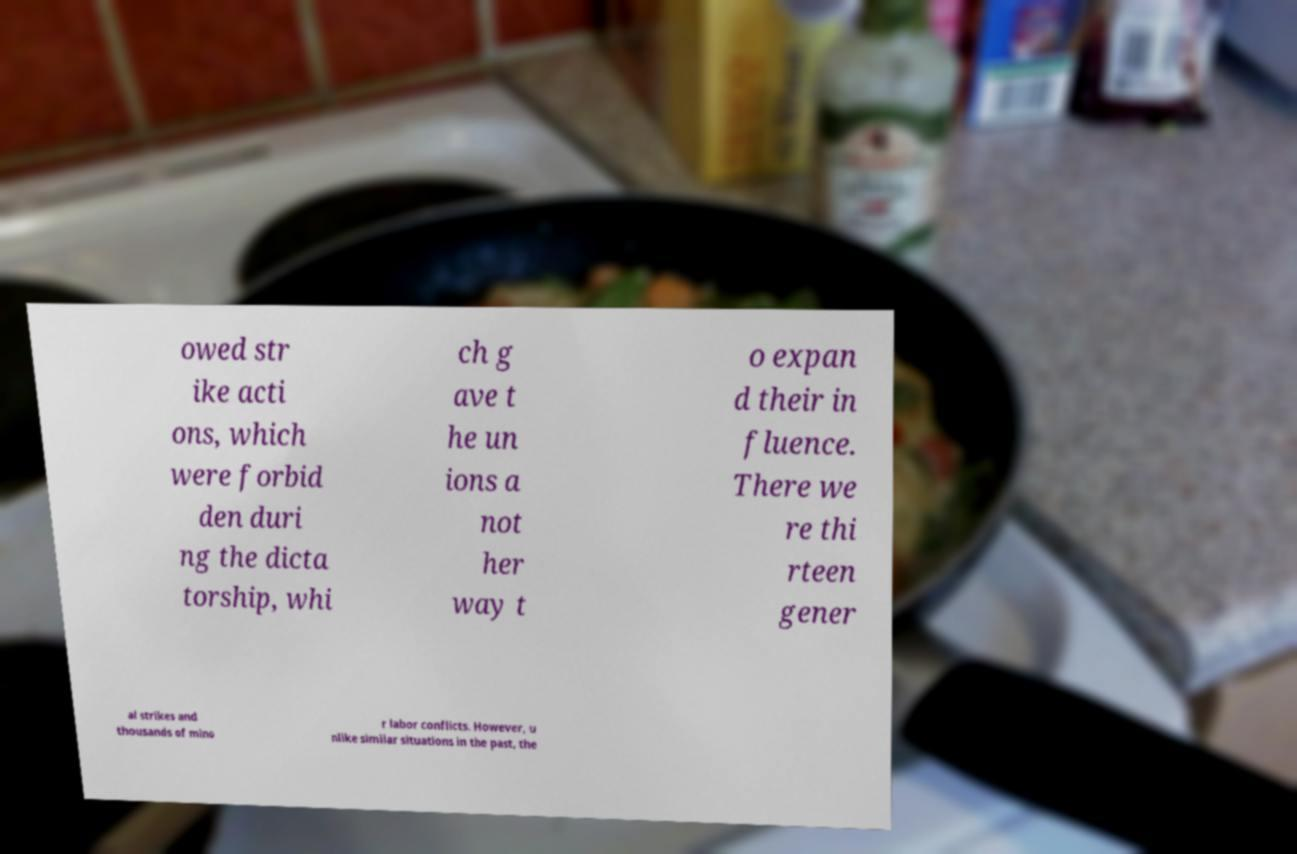Can you read and provide the text displayed in the image?This photo seems to have some interesting text. Can you extract and type it out for me? owed str ike acti ons, which were forbid den duri ng the dicta torship, whi ch g ave t he un ions a not her way t o expan d their in fluence. There we re thi rteen gener al strikes and thousands of mino r labor conflicts. However, u nlike similar situations in the past, the 